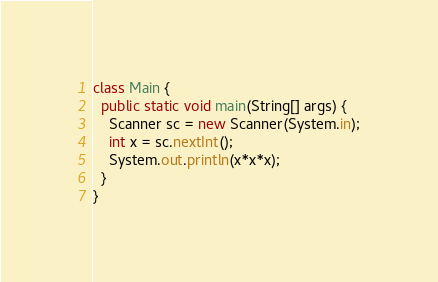<code> <loc_0><loc_0><loc_500><loc_500><_Java_>class Main {
  public static void main(String[] args) {
    Scanner sc = new Scanner(System.in);
    int x = sc.nextInt();
    System.out.println(x*x*x);
  }
}
</code> 